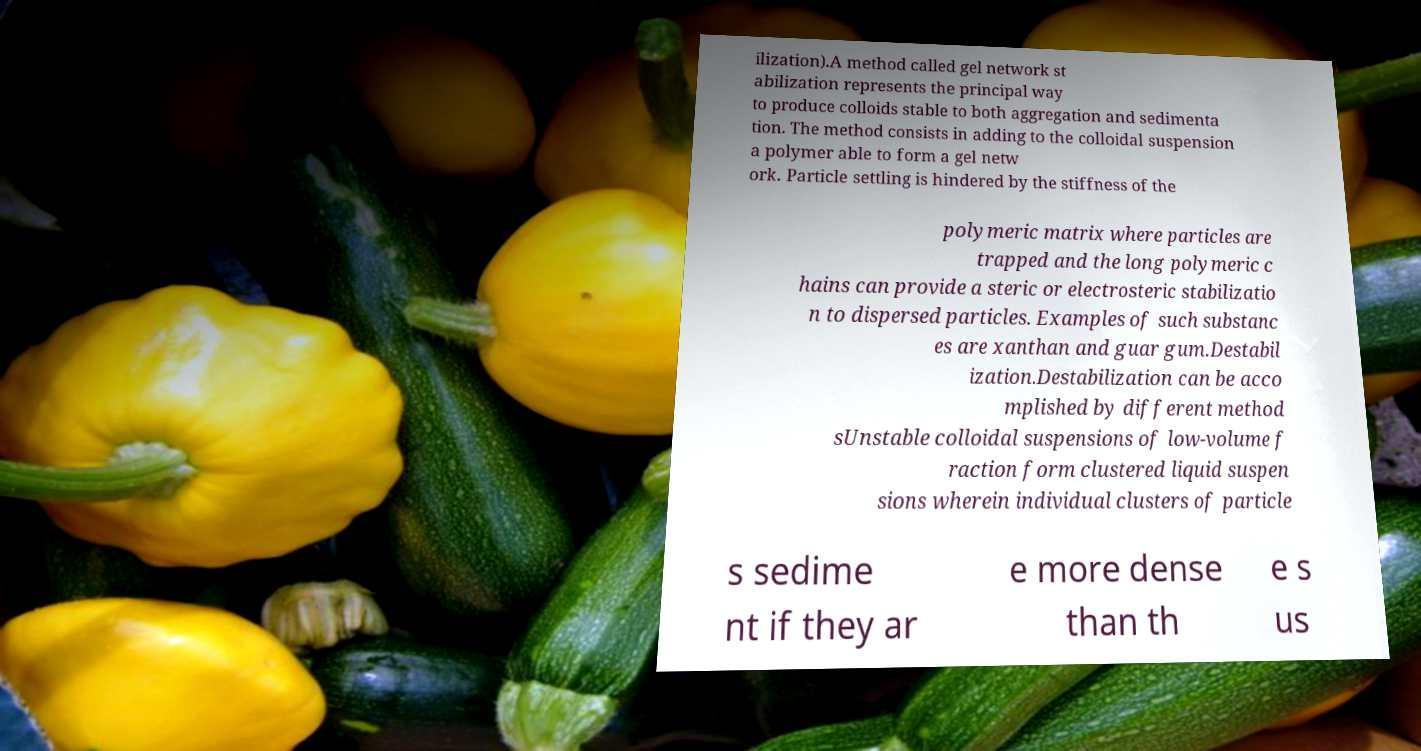Please read and relay the text visible in this image. What does it say? ilization).A method called gel network st abilization represents the principal way to produce colloids stable to both aggregation and sedimenta tion. The method consists in adding to the colloidal suspension a polymer able to form a gel netw ork. Particle settling is hindered by the stiffness of the polymeric matrix where particles are trapped and the long polymeric c hains can provide a steric or electrosteric stabilizatio n to dispersed particles. Examples of such substanc es are xanthan and guar gum.Destabil ization.Destabilization can be acco mplished by different method sUnstable colloidal suspensions of low-volume f raction form clustered liquid suspen sions wherein individual clusters of particle s sedime nt if they ar e more dense than th e s us 